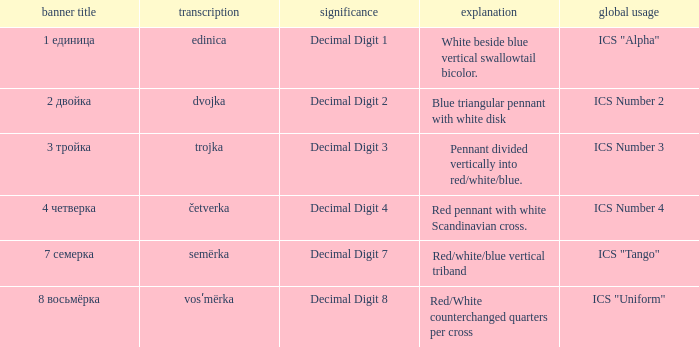What are the meanings of the flag whose name transliterates to semërka? Decimal Digit 7. 